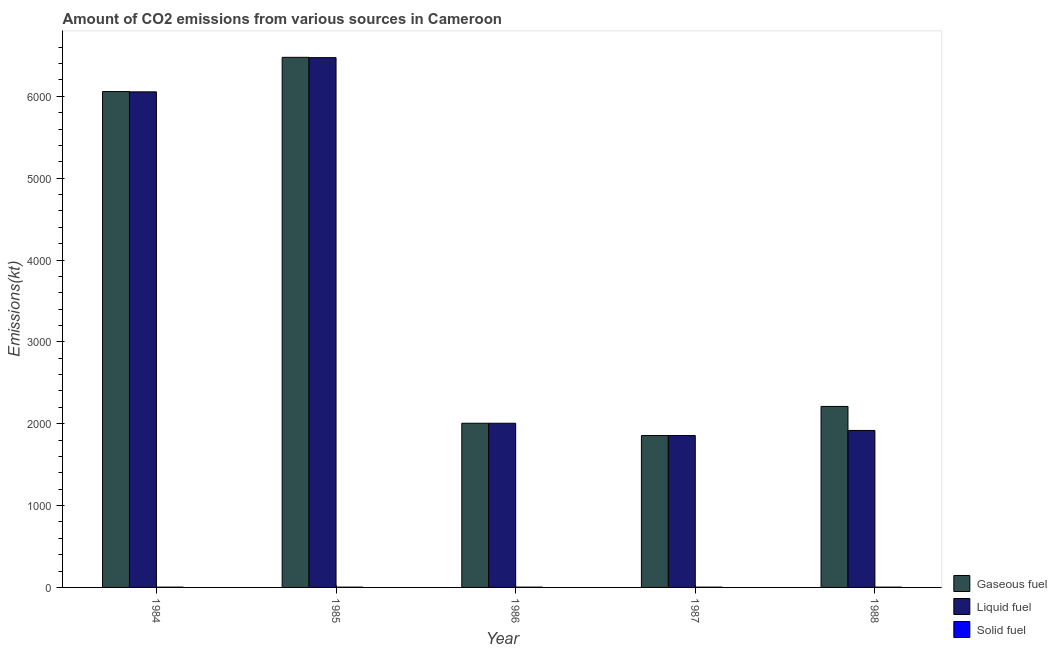How many different coloured bars are there?
Offer a terse response. 3. What is the amount of co2 emissions from solid fuel in 1984?
Give a very brief answer. 3.67. Across all years, what is the maximum amount of co2 emissions from solid fuel?
Your answer should be very brief. 3.67. Across all years, what is the minimum amount of co2 emissions from liquid fuel?
Your answer should be very brief. 1855.5. In which year was the amount of co2 emissions from solid fuel maximum?
Keep it short and to the point. 1984. What is the total amount of co2 emissions from gaseous fuel in the graph?
Your answer should be very brief. 1.86e+04. What is the difference between the amount of co2 emissions from gaseous fuel in 1985 and that in 1988?
Keep it short and to the point. 4264.72. What is the difference between the amount of co2 emissions from gaseous fuel in 1988 and the amount of co2 emissions from liquid fuel in 1987?
Give a very brief answer. 355.7. What is the average amount of co2 emissions from gaseous fuel per year?
Make the answer very short. 3721.27. In the year 1985, what is the difference between the amount of co2 emissions from liquid fuel and amount of co2 emissions from gaseous fuel?
Offer a very short reply. 0. In how many years, is the amount of co2 emissions from liquid fuel greater than 3200 kt?
Provide a succinct answer. 2. What is the ratio of the amount of co2 emissions from gaseous fuel in 1984 to that in 1988?
Offer a terse response. 2.74. Is the amount of co2 emissions from liquid fuel in 1984 less than that in 1987?
Ensure brevity in your answer.  No. Is the difference between the amount of co2 emissions from gaseous fuel in 1984 and 1985 greater than the difference between the amount of co2 emissions from solid fuel in 1984 and 1985?
Your answer should be compact. No. What is the difference between the highest and the second highest amount of co2 emissions from gaseous fuel?
Ensure brevity in your answer.  418.04. What is the difference between the highest and the lowest amount of co2 emissions from liquid fuel?
Your answer should be very brief. 4616.75. What does the 3rd bar from the left in 1987 represents?
Make the answer very short. Solid fuel. What does the 3rd bar from the right in 1988 represents?
Provide a short and direct response. Gaseous fuel. Are all the bars in the graph horizontal?
Your answer should be very brief. No. How many years are there in the graph?
Your answer should be compact. 5. What is the difference between two consecutive major ticks on the Y-axis?
Ensure brevity in your answer.  1000. Are the values on the major ticks of Y-axis written in scientific E-notation?
Offer a terse response. No. How are the legend labels stacked?
Offer a very short reply. Vertical. What is the title of the graph?
Your answer should be compact. Amount of CO2 emissions from various sources in Cameroon. What is the label or title of the Y-axis?
Provide a succinct answer. Emissions(kt). What is the Emissions(kt) of Gaseous fuel in 1984?
Offer a terse response. 6057.88. What is the Emissions(kt) in Liquid fuel in 1984?
Give a very brief answer. 6054.22. What is the Emissions(kt) in Solid fuel in 1984?
Offer a terse response. 3.67. What is the Emissions(kt) in Gaseous fuel in 1985?
Your response must be concise. 6475.92. What is the Emissions(kt) of Liquid fuel in 1985?
Make the answer very short. 6472.26. What is the Emissions(kt) of Solid fuel in 1985?
Offer a terse response. 3.67. What is the Emissions(kt) of Gaseous fuel in 1986?
Offer a terse response. 2005.85. What is the Emissions(kt) of Liquid fuel in 1986?
Your answer should be very brief. 2005.85. What is the Emissions(kt) of Solid fuel in 1986?
Provide a short and direct response. 3.67. What is the Emissions(kt) of Gaseous fuel in 1987?
Make the answer very short. 1855.5. What is the Emissions(kt) in Liquid fuel in 1987?
Ensure brevity in your answer.  1855.5. What is the Emissions(kt) in Solid fuel in 1987?
Ensure brevity in your answer.  3.67. What is the Emissions(kt) in Gaseous fuel in 1988?
Provide a succinct answer. 2211.2. What is the Emissions(kt) in Liquid fuel in 1988?
Provide a succinct answer. 1917.84. What is the Emissions(kt) of Solid fuel in 1988?
Give a very brief answer. 3.67. Across all years, what is the maximum Emissions(kt) in Gaseous fuel?
Offer a very short reply. 6475.92. Across all years, what is the maximum Emissions(kt) of Liquid fuel?
Keep it short and to the point. 6472.26. Across all years, what is the maximum Emissions(kt) of Solid fuel?
Make the answer very short. 3.67. Across all years, what is the minimum Emissions(kt) of Gaseous fuel?
Provide a succinct answer. 1855.5. Across all years, what is the minimum Emissions(kt) of Liquid fuel?
Provide a succinct answer. 1855.5. Across all years, what is the minimum Emissions(kt) of Solid fuel?
Make the answer very short. 3.67. What is the total Emissions(kt) in Gaseous fuel in the graph?
Give a very brief answer. 1.86e+04. What is the total Emissions(kt) in Liquid fuel in the graph?
Give a very brief answer. 1.83e+04. What is the total Emissions(kt) of Solid fuel in the graph?
Your answer should be very brief. 18.34. What is the difference between the Emissions(kt) in Gaseous fuel in 1984 and that in 1985?
Your response must be concise. -418.04. What is the difference between the Emissions(kt) of Liquid fuel in 1984 and that in 1985?
Offer a terse response. -418.04. What is the difference between the Emissions(kt) in Gaseous fuel in 1984 and that in 1986?
Make the answer very short. 4052.03. What is the difference between the Emissions(kt) of Liquid fuel in 1984 and that in 1986?
Make the answer very short. 4048.37. What is the difference between the Emissions(kt) in Gaseous fuel in 1984 and that in 1987?
Your response must be concise. 4202.38. What is the difference between the Emissions(kt) in Liquid fuel in 1984 and that in 1987?
Your answer should be very brief. 4198.72. What is the difference between the Emissions(kt) in Gaseous fuel in 1984 and that in 1988?
Ensure brevity in your answer.  3846.68. What is the difference between the Emissions(kt) in Liquid fuel in 1984 and that in 1988?
Give a very brief answer. 4136.38. What is the difference between the Emissions(kt) in Gaseous fuel in 1985 and that in 1986?
Offer a very short reply. 4470.07. What is the difference between the Emissions(kt) in Liquid fuel in 1985 and that in 1986?
Your response must be concise. 4466.41. What is the difference between the Emissions(kt) in Gaseous fuel in 1985 and that in 1987?
Give a very brief answer. 4620.42. What is the difference between the Emissions(kt) of Liquid fuel in 1985 and that in 1987?
Your answer should be compact. 4616.75. What is the difference between the Emissions(kt) of Solid fuel in 1985 and that in 1987?
Provide a succinct answer. 0. What is the difference between the Emissions(kt) of Gaseous fuel in 1985 and that in 1988?
Your response must be concise. 4264.72. What is the difference between the Emissions(kt) in Liquid fuel in 1985 and that in 1988?
Your answer should be compact. 4554.41. What is the difference between the Emissions(kt) of Solid fuel in 1985 and that in 1988?
Make the answer very short. 0. What is the difference between the Emissions(kt) in Gaseous fuel in 1986 and that in 1987?
Your answer should be very brief. 150.35. What is the difference between the Emissions(kt) in Liquid fuel in 1986 and that in 1987?
Provide a succinct answer. 150.35. What is the difference between the Emissions(kt) of Gaseous fuel in 1986 and that in 1988?
Make the answer very short. -205.35. What is the difference between the Emissions(kt) in Liquid fuel in 1986 and that in 1988?
Provide a succinct answer. 88.01. What is the difference between the Emissions(kt) of Solid fuel in 1986 and that in 1988?
Provide a short and direct response. 0. What is the difference between the Emissions(kt) in Gaseous fuel in 1987 and that in 1988?
Provide a short and direct response. -355.7. What is the difference between the Emissions(kt) of Liquid fuel in 1987 and that in 1988?
Offer a very short reply. -62.34. What is the difference between the Emissions(kt) in Solid fuel in 1987 and that in 1988?
Make the answer very short. 0. What is the difference between the Emissions(kt) of Gaseous fuel in 1984 and the Emissions(kt) of Liquid fuel in 1985?
Keep it short and to the point. -414.37. What is the difference between the Emissions(kt) of Gaseous fuel in 1984 and the Emissions(kt) of Solid fuel in 1985?
Your response must be concise. 6054.22. What is the difference between the Emissions(kt) in Liquid fuel in 1984 and the Emissions(kt) in Solid fuel in 1985?
Keep it short and to the point. 6050.55. What is the difference between the Emissions(kt) of Gaseous fuel in 1984 and the Emissions(kt) of Liquid fuel in 1986?
Give a very brief answer. 4052.03. What is the difference between the Emissions(kt) of Gaseous fuel in 1984 and the Emissions(kt) of Solid fuel in 1986?
Offer a very short reply. 6054.22. What is the difference between the Emissions(kt) of Liquid fuel in 1984 and the Emissions(kt) of Solid fuel in 1986?
Make the answer very short. 6050.55. What is the difference between the Emissions(kt) in Gaseous fuel in 1984 and the Emissions(kt) in Liquid fuel in 1987?
Offer a terse response. 4202.38. What is the difference between the Emissions(kt) of Gaseous fuel in 1984 and the Emissions(kt) of Solid fuel in 1987?
Offer a terse response. 6054.22. What is the difference between the Emissions(kt) of Liquid fuel in 1984 and the Emissions(kt) of Solid fuel in 1987?
Offer a very short reply. 6050.55. What is the difference between the Emissions(kt) of Gaseous fuel in 1984 and the Emissions(kt) of Liquid fuel in 1988?
Your answer should be very brief. 4140.04. What is the difference between the Emissions(kt) of Gaseous fuel in 1984 and the Emissions(kt) of Solid fuel in 1988?
Keep it short and to the point. 6054.22. What is the difference between the Emissions(kt) in Liquid fuel in 1984 and the Emissions(kt) in Solid fuel in 1988?
Provide a short and direct response. 6050.55. What is the difference between the Emissions(kt) in Gaseous fuel in 1985 and the Emissions(kt) in Liquid fuel in 1986?
Give a very brief answer. 4470.07. What is the difference between the Emissions(kt) of Gaseous fuel in 1985 and the Emissions(kt) of Solid fuel in 1986?
Your answer should be very brief. 6472.26. What is the difference between the Emissions(kt) in Liquid fuel in 1985 and the Emissions(kt) in Solid fuel in 1986?
Your answer should be compact. 6468.59. What is the difference between the Emissions(kt) in Gaseous fuel in 1985 and the Emissions(kt) in Liquid fuel in 1987?
Provide a short and direct response. 4620.42. What is the difference between the Emissions(kt) in Gaseous fuel in 1985 and the Emissions(kt) in Solid fuel in 1987?
Provide a short and direct response. 6472.26. What is the difference between the Emissions(kt) of Liquid fuel in 1985 and the Emissions(kt) of Solid fuel in 1987?
Provide a succinct answer. 6468.59. What is the difference between the Emissions(kt) of Gaseous fuel in 1985 and the Emissions(kt) of Liquid fuel in 1988?
Provide a short and direct response. 4558.08. What is the difference between the Emissions(kt) in Gaseous fuel in 1985 and the Emissions(kt) in Solid fuel in 1988?
Offer a terse response. 6472.26. What is the difference between the Emissions(kt) of Liquid fuel in 1985 and the Emissions(kt) of Solid fuel in 1988?
Your answer should be very brief. 6468.59. What is the difference between the Emissions(kt) of Gaseous fuel in 1986 and the Emissions(kt) of Liquid fuel in 1987?
Your response must be concise. 150.35. What is the difference between the Emissions(kt) of Gaseous fuel in 1986 and the Emissions(kt) of Solid fuel in 1987?
Your answer should be very brief. 2002.18. What is the difference between the Emissions(kt) of Liquid fuel in 1986 and the Emissions(kt) of Solid fuel in 1987?
Keep it short and to the point. 2002.18. What is the difference between the Emissions(kt) in Gaseous fuel in 1986 and the Emissions(kt) in Liquid fuel in 1988?
Keep it short and to the point. 88.01. What is the difference between the Emissions(kt) of Gaseous fuel in 1986 and the Emissions(kt) of Solid fuel in 1988?
Ensure brevity in your answer.  2002.18. What is the difference between the Emissions(kt) in Liquid fuel in 1986 and the Emissions(kt) in Solid fuel in 1988?
Your response must be concise. 2002.18. What is the difference between the Emissions(kt) of Gaseous fuel in 1987 and the Emissions(kt) of Liquid fuel in 1988?
Provide a short and direct response. -62.34. What is the difference between the Emissions(kt) of Gaseous fuel in 1987 and the Emissions(kt) of Solid fuel in 1988?
Provide a succinct answer. 1851.84. What is the difference between the Emissions(kt) in Liquid fuel in 1987 and the Emissions(kt) in Solid fuel in 1988?
Keep it short and to the point. 1851.84. What is the average Emissions(kt) of Gaseous fuel per year?
Provide a short and direct response. 3721.27. What is the average Emissions(kt) of Liquid fuel per year?
Keep it short and to the point. 3661.13. What is the average Emissions(kt) in Solid fuel per year?
Make the answer very short. 3.67. In the year 1984, what is the difference between the Emissions(kt) in Gaseous fuel and Emissions(kt) in Liquid fuel?
Make the answer very short. 3.67. In the year 1984, what is the difference between the Emissions(kt) of Gaseous fuel and Emissions(kt) of Solid fuel?
Make the answer very short. 6054.22. In the year 1984, what is the difference between the Emissions(kt) in Liquid fuel and Emissions(kt) in Solid fuel?
Your response must be concise. 6050.55. In the year 1985, what is the difference between the Emissions(kt) in Gaseous fuel and Emissions(kt) in Liquid fuel?
Offer a terse response. 3.67. In the year 1985, what is the difference between the Emissions(kt) in Gaseous fuel and Emissions(kt) in Solid fuel?
Keep it short and to the point. 6472.26. In the year 1985, what is the difference between the Emissions(kt) of Liquid fuel and Emissions(kt) of Solid fuel?
Your answer should be very brief. 6468.59. In the year 1986, what is the difference between the Emissions(kt) in Gaseous fuel and Emissions(kt) in Solid fuel?
Keep it short and to the point. 2002.18. In the year 1986, what is the difference between the Emissions(kt) of Liquid fuel and Emissions(kt) of Solid fuel?
Ensure brevity in your answer.  2002.18. In the year 1987, what is the difference between the Emissions(kt) of Gaseous fuel and Emissions(kt) of Solid fuel?
Give a very brief answer. 1851.84. In the year 1987, what is the difference between the Emissions(kt) in Liquid fuel and Emissions(kt) in Solid fuel?
Keep it short and to the point. 1851.84. In the year 1988, what is the difference between the Emissions(kt) in Gaseous fuel and Emissions(kt) in Liquid fuel?
Your answer should be compact. 293.36. In the year 1988, what is the difference between the Emissions(kt) of Gaseous fuel and Emissions(kt) of Solid fuel?
Provide a succinct answer. 2207.53. In the year 1988, what is the difference between the Emissions(kt) of Liquid fuel and Emissions(kt) of Solid fuel?
Offer a very short reply. 1914.17. What is the ratio of the Emissions(kt) of Gaseous fuel in 1984 to that in 1985?
Keep it short and to the point. 0.94. What is the ratio of the Emissions(kt) of Liquid fuel in 1984 to that in 1985?
Your answer should be compact. 0.94. What is the ratio of the Emissions(kt) in Solid fuel in 1984 to that in 1985?
Your answer should be very brief. 1. What is the ratio of the Emissions(kt) in Gaseous fuel in 1984 to that in 1986?
Keep it short and to the point. 3.02. What is the ratio of the Emissions(kt) in Liquid fuel in 1984 to that in 1986?
Provide a succinct answer. 3.02. What is the ratio of the Emissions(kt) in Gaseous fuel in 1984 to that in 1987?
Provide a succinct answer. 3.26. What is the ratio of the Emissions(kt) of Liquid fuel in 1984 to that in 1987?
Keep it short and to the point. 3.26. What is the ratio of the Emissions(kt) in Gaseous fuel in 1984 to that in 1988?
Offer a terse response. 2.74. What is the ratio of the Emissions(kt) of Liquid fuel in 1984 to that in 1988?
Ensure brevity in your answer.  3.16. What is the ratio of the Emissions(kt) of Solid fuel in 1984 to that in 1988?
Your response must be concise. 1. What is the ratio of the Emissions(kt) in Gaseous fuel in 1985 to that in 1986?
Offer a very short reply. 3.23. What is the ratio of the Emissions(kt) of Liquid fuel in 1985 to that in 1986?
Provide a short and direct response. 3.23. What is the ratio of the Emissions(kt) in Solid fuel in 1985 to that in 1986?
Your response must be concise. 1. What is the ratio of the Emissions(kt) in Gaseous fuel in 1985 to that in 1987?
Provide a short and direct response. 3.49. What is the ratio of the Emissions(kt) in Liquid fuel in 1985 to that in 1987?
Offer a terse response. 3.49. What is the ratio of the Emissions(kt) in Solid fuel in 1985 to that in 1987?
Provide a short and direct response. 1. What is the ratio of the Emissions(kt) in Gaseous fuel in 1985 to that in 1988?
Your answer should be very brief. 2.93. What is the ratio of the Emissions(kt) of Liquid fuel in 1985 to that in 1988?
Give a very brief answer. 3.37. What is the ratio of the Emissions(kt) of Gaseous fuel in 1986 to that in 1987?
Your answer should be compact. 1.08. What is the ratio of the Emissions(kt) in Liquid fuel in 1986 to that in 1987?
Provide a succinct answer. 1.08. What is the ratio of the Emissions(kt) in Solid fuel in 1986 to that in 1987?
Your answer should be very brief. 1. What is the ratio of the Emissions(kt) in Gaseous fuel in 1986 to that in 1988?
Ensure brevity in your answer.  0.91. What is the ratio of the Emissions(kt) of Liquid fuel in 1986 to that in 1988?
Keep it short and to the point. 1.05. What is the ratio of the Emissions(kt) of Gaseous fuel in 1987 to that in 1988?
Offer a terse response. 0.84. What is the ratio of the Emissions(kt) in Liquid fuel in 1987 to that in 1988?
Make the answer very short. 0.97. What is the difference between the highest and the second highest Emissions(kt) of Gaseous fuel?
Your answer should be compact. 418.04. What is the difference between the highest and the second highest Emissions(kt) in Liquid fuel?
Offer a terse response. 418.04. What is the difference between the highest and the second highest Emissions(kt) of Solid fuel?
Offer a terse response. 0. What is the difference between the highest and the lowest Emissions(kt) of Gaseous fuel?
Offer a very short reply. 4620.42. What is the difference between the highest and the lowest Emissions(kt) of Liquid fuel?
Give a very brief answer. 4616.75. 